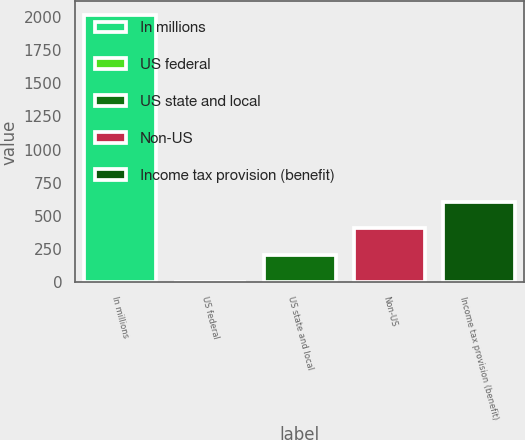<chart> <loc_0><loc_0><loc_500><loc_500><bar_chart><fcel>In millions<fcel>US federal<fcel>US state and local<fcel>Non-US<fcel>Income tax provision (benefit)<nl><fcel>2016<fcel>7<fcel>207.9<fcel>408.8<fcel>609.7<nl></chart> 